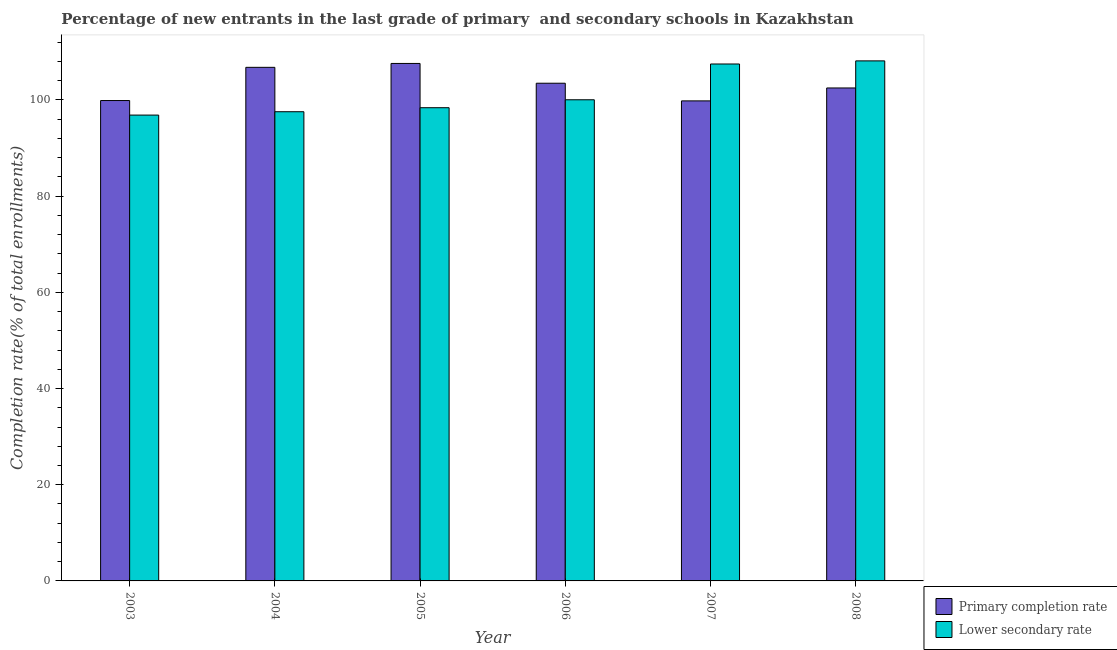How many different coloured bars are there?
Give a very brief answer. 2. Are the number of bars on each tick of the X-axis equal?
Offer a very short reply. Yes. How many bars are there on the 3rd tick from the right?
Offer a terse response. 2. In how many cases, is the number of bars for a given year not equal to the number of legend labels?
Make the answer very short. 0. What is the completion rate in primary schools in 2004?
Provide a succinct answer. 106.78. Across all years, what is the maximum completion rate in primary schools?
Provide a succinct answer. 107.58. Across all years, what is the minimum completion rate in primary schools?
Your answer should be compact. 99.8. In which year was the completion rate in primary schools maximum?
Give a very brief answer. 2005. In which year was the completion rate in primary schools minimum?
Make the answer very short. 2007. What is the total completion rate in secondary schools in the graph?
Give a very brief answer. 608.39. What is the difference between the completion rate in primary schools in 2006 and that in 2007?
Provide a short and direct response. 3.67. What is the difference between the completion rate in primary schools in 2005 and the completion rate in secondary schools in 2008?
Your response must be concise. 5.1. What is the average completion rate in secondary schools per year?
Offer a terse response. 101.4. In the year 2004, what is the difference between the completion rate in primary schools and completion rate in secondary schools?
Your answer should be compact. 0. In how many years, is the completion rate in primary schools greater than 108 %?
Provide a succinct answer. 0. What is the ratio of the completion rate in secondary schools in 2004 to that in 2008?
Make the answer very short. 0.9. Is the completion rate in primary schools in 2004 less than that in 2005?
Your answer should be very brief. Yes. Is the difference between the completion rate in primary schools in 2004 and 2008 greater than the difference between the completion rate in secondary schools in 2004 and 2008?
Your answer should be very brief. No. What is the difference between the highest and the second highest completion rate in secondary schools?
Ensure brevity in your answer.  0.65. What is the difference between the highest and the lowest completion rate in secondary schools?
Your answer should be compact. 11.27. In how many years, is the completion rate in primary schools greater than the average completion rate in primary schools taken over all years?
Ensure brevity in your answer.  3. Is the sum of the completion rate in secondary schools in 2004 and 2008 greater than the maximum completion rate in primary schools across all years?
Give a very brief answer. Yes. What does the 2nd bar from the left in 2005 represents?
Your answer should be very brief. Lower secondary rate. What does the 1st bar from the right in 2005 represents?
Your answer should be compact. Lower secondary rate. Are all the bars in the graph horizontal?
Your answer should be very brief. No. Does the graph contain any zero values?
Keep it short and to the point. No. Does the graph contain grids?
Provide a succinct answer. No. Where does the legend appear in the graph?
Make the answer very short. Bottom right. What is the title of the graph?
Keep it short and to the point. Percentage of new entrants in the last grade of primary  and secondary schools in Kazakhstan. What is the label or title of the Y-axis?
Provide a succinct answer. Completion rate(% of total enrollments). What is the Completion rate(% of total enrollments) of Primary completion rate in 2003?
Your answer should be very brief. 99.87. What is the Completion rate(% of total enrollments) of Lower secondary rate in 2003?
Make the answer very short. 96.85. What is the Completion rate(% of total enrollments) of Primary completion rate in 2004?
Your answer should be compact. 106.78. What is the Completion rate(% of total enrollments) of Lower secondary rate in 2004?
Offer a very short reply. 97.55. What is the Completion rate(% of total enrollments) in Primary completion rate in 2005?
Your response must be concise. 107.58. What is the Completion rate(% of total enrollments) of Lower secondary rate in 2005?
Your response must be concise. 98.38. What is the Completion rate(% of total enrollments) in Primary completion rate in 2006?
Offer a very short reply. 103.47. What is the Completion rate(% of total enrollments) in Lower secondary rate in 2006?
Your answer should be very brief. 100.03. What is the Completion rate(% of total enrollments) in Primary completion rate in 2007?
Give a very brief answer. 99.8. What is the Completion rate(% of total enrollments) in Lower secondary rate in 2007?
Offer a terse response. 107.47. What is the Completion rate(% of total enrollments) of Primary completion rate in 2008?
Your response must be concise. 102.49. What is the Completion rate(% of total enrollments) of Lower secondary rate in 2008?
Ensure brevity in your answer.  108.12. Across all years, what is the maximum Completion rate(% of total enrollments) of Primary completion rate?
Your response must be concise. 107.58. Across all years, what is the maximum Completion rate(% of total enrollments) of Lower secondary rate?
Your answer should be compact. 108.12. Across all years, what is the minimum Completion rate(% of total enrollments) in Primary completion rate?
Make the answer very short. 99.8. Across all years, what is the minimum Completion rate(% of total enrollments) in Lower secondary rate?
Keep it short and to the point. 96.85. What is the total Completion rate(% of total enrollments) in Primary completion rate in the graph?
Offer a very short reply. 619.99. What is the total Completion rate(% of total enrollments) in Lower secondary rate in the graph?
Keep it short and to the point. 608.39. What is the difference between the Completion rate(% of total enrollments) in Primary completion rate in 2003 and that in 2004?
Make the answer very short. -6.9. What is the difference between the Completion rate(% of total enrollments) of Lower secondary rate in 2003 and that in 2004?
Keep it short and to the point. -0.7. What is the difference between the Completion rate(% of total enrollments) in Primary completion rate in 2003 and that in 2005?
Your answer should be compact. -7.71. What is the difference between the Completion rate(% of total enrollments) in Lower secondary rate in 2003 and that in 2005?
Keep it short and to the point. -1.53. What is the difference between the Completion rate(% of total enrollments) of Primary completion rate in 2003 and that in 2006?
Offer a terse response. -3.6. What is the difference between the Completion rate(% of total enrollments) in Lower secondary rate in 2003 and that in 2006?
Your answer should be very brief. -3.18. What is the difference between the Completion rate(% of total enrollments) of Primary completion rate in 2003 and that in 2007?
Your response must be concise. 0.07. What is the difference between the Completion rate(% of total enrollments) in Lower secondary rate in 2003 and that in 2007?
Your answer should be compact. -10.62. What is the difference between the Completion rate(% of total enrollments) in Primary completion rate in 2003 and that in 2008?
Ensure brevity in your answer.  -2.61. What is the difference between the Completion rate(% of total enrollments) in Lower secondary rate in 2003 and that in 2008?
Offer a very short reply. -11.27. What is the difference between the Completion rate(% of total enrollments) in Primary completion rate in 2004 and that in 2005?
Offer a very short reply. -0.81. What is the difference between the Completion rate(% of total enrollments) in Lower secondary rate in 2004 and that in 2005?
Provide a short and direct response. -0.83. What is the difference between the Completion rate(% of total enrollments) of Primary completion rate in 2004 and that in 2006?
Provide a short and direct response. 3.31. What is the difference between the Completion rate(% of total enrollments) in Lower secondary rate in 2004 and that in 2006?
Offer a terse response. -2.49. What is the difference between the Completion rate(% of total enrollments) of Primary completion rate in 2004 and that in 2007?
Provide a succinct answer. 6.98. What is the difference between the Completion rate(% of total enrollments) in Lower secondary rate in 2004 and that in 2007?
Provide a succinct answer. -9.92. What is the difference between the Completion rate(% of total enrollments) of Primary completion rate in 2004 and that in 2008?
Provide a succinct answer. 4.29. What is the difference between the Completion rate(% of total enrollments) in Lower secondary rate in 2004 and that in 2008?
Keep it short and to the point. -10.57. What is the difference between the Completion rate(% of total enrollments) of Primary completion rate in 2005 and that in 2006?
Your answer should be very brief. 4.11. What is the difference between the Completion rate(% of total enrollments) in Lower secondary rate in 2005 and that in 2006?
Your response must be concise. -1.65. What is the difference between the Completion rate(% of total enrollments) of Primary completion rate in 2005 and that in 2007?
Provide a short and direct response. 7.78. What is the difference between the Completion rate(% of total enrollments) of Lower secondary rate in 2005 and that in 2007?
Your answer should be compact. -9.09. What is the difference between the Completion rate(% of total enrollments) of Primary completion rate in 2005 and that in 2008?
Your response must be concise. 5.1. What is the difference between the Completion rate(% of total enrollments) in Lower secondary rate in 2005 and that in 2008?
Your answer should be very brief. -9.74. What is the difference between the Completion rate(% of total enrollments) in Primary completion rate in 2006 and that in 2007?
Your answer should be very brief. 3.67. What is the difference between the Completion rate(% of total enrollments) in Lower secondary rate in 2006 and that in 2007?
Keep it short and to the point. -7.44. What is the difference between the Completion rate(% of total enrollments) in Primary completion rate in 2006 and that in 2008?
Keep it short and to the point. 0.98. What is the difference between the Completion rate(% of total enrollments) of Lower secondary rate in 2006 and that in 2008?
Offer a terse response. -8.09. What is the difference between the Completion rate(% of total enrollments) of Primary completion rate in 2007 and that in 2008?
Keep it short and to the point. -2.69. What is the difference between the Completion rate(% of total enrollments) in Lower secondary rate in 2007 and that in 2008?
Your answer should be compact. -0.65. What is the difference between the Completion rate(% of total enrollments) of Primary completion rate in 2003 and the Completion rate(% of total enrollments) of Lower secondary rate in 2004?
Your response must be concise. 2.33. What is the difference between the Completion rate(% of total enrollments) in Primary completion rate in 2003 and the Completion rate(% of total enrollments) in Lower secondary rate in 2005?
Keep it short and to the point. 1.49. What is the difference between the Completion rate(% of total enrollments) of Primary completion rate in 2003 and the Completion rate(% of total enrollments) of Lower secondary rate in 2006?
Your answer should be compact. -0.16. What is the difference between the Completion rate(% of total enrollments) in Primary completion rate in 2003 and the Completion rate(% of total enrollments) in Lower secondary rate in 2007?
Your answer should be compact. -7.6. What is the difference between the Completion rate(% of total enrollments) in Primary completion rate in 2003 and the Completion rate(% of total enrollments) in Lower secondary rate in 2008?
Provide a succinct answer. -8.25. What is the difference between the Completion rate(% of total enrollments) of Primary completion rate in 2004 and the Completion rate(% of total enrollments) of Lower secondary rate in 2005?
Your answer should be very brief. 8.4. What is the difference between the Completion rate(% of total enrollments) of Primary completion rate in 2004 and the Completion rate(% of total enrollments) of Lower secondary rate in 2006?
Your answer should be very brief. 6.74. What is the difference between the Completion rate(% of total enrollments) in Primary completion rate in 2004 and the Completion rate(% of total enrollments) in Lower secondary rate in 2007?
Your answer should be compact. -0.69. What is the difference between the Completion rate(% of total enrollments) of Primary completion rate in 2004 and the Completion rate(% of total enrollments) of Lower secondary rate in 2008?
Provide a succinct answer. -1.34. What is the difference between the Completion rate(% of total enrollments) of Primary completion rate in 2005 and the Completion rate(% of total enrollments) of Lower secondary rate in 2006?
Make the answer very short. 7.55. What is the difference between the Completion rate(% of total enrollments) in Primary completion rate in 2005 and the Completion rate(% of total enrollments) in Lower secondary rate in 2007?
Ensure brevity in your answer.  0.11. What is the difference between the Completion rate(% of total enrollments) of Primary completion rate in 2005 and the Completion rate(% of total enrollments) of Lower secondary rate in 2008?
Give a very brief answer. -0.53. What is the difference between the Completion rate(% of total enrollments) in Primary completion rate in 2006 and the Completion rate(% of total enrollments) in Lower secondary rate in 2007?
Your response must be concise. -4. What is the difference between the Completion rate(% of total enrollments) in Primary completion rate in 2006 and the Completion rate(% of total enrollments) in Lower secondary rate in 2008?
Ensure brevity in your answer.  -4.65. What is the difference between the Completion rate(% of total enrollments) of Primary completion rate in 2007 and the Completion rate(% of total enrollments) of Lower secondary rate in 2008?
Provide a succinct answer. -8.32. What is the average Completion rate(% of total enrollments) in Primary completion rate per year?
Your answer should be compact. 103.33. What is the average Completion rate(% of total enrollments) in Lower secondary rate per year?
Keep it short and to the point. 101.4. In the year 2003, what is the difference between the Completion rate(% of total enrollments) in Primary completion rate and Completion rate(% of total enrollments) in Lower secondary rate?
Give a very brief answer. 3.02. In the year 2004, what is the difference between the Completion rate(% of total enrollments) of Primary completion rate and Completion rate(% of total enrollments) of Lower secondary rate?
Your response must be concise. 9.23. In the year 2005, what is the difference between the Completion rate(% of total enrollments) in Primary completion rate and Completion rate(% of total enrollments) in Lower secondary rate?
Make the answer very short. 9.2. In the year 2006, what is the difference between the Completion rate(% of total enrollments) in Primary completion rate and Completion rate(% of total enrollments) in Lower secondary rate?
Ensure brevity in your answer.  3.44. In the year 2007, what is the difference between the Completion rate(% of total enrollments) of Primary completion rate and Completion rate(% of total enrollments) of Lower secondary rate?
Provide a succinct answer. -7.67. In the year 2008, what is the difference between the Completion rate(% of total enrollments) in Primary completion rate and Completion rate(% of total enrollments) in Lower secondary rate?
Offer a terse response. -5.63. What is the ratio of the Completion rate(% of total enrollments) in Primary completion rate in 2003 to that in 2004?
Ensure brevity in your answer.  0.94. What is the ratio of the Completion rate(% of total enrollments) in Lower secondary rate in 2003 to that in 2004?
Your response must be concise. 0.99. What is the ratio of the Completion rate(% of total enrollments) in Primary completion rate in 2003 to that in 2005?
Your answer should be compact. 0.93. What is the ratio of the Completion rate(% of total enrollments) of Lower secondary rate in 2003 to that in 2005?
Keep it short and to the point. 0.98. What is the ratio of the Completion rate(% of total enrollments) of Primary completion rate in 2003 to that in 2006?
Give a very brief answer. 0.97. What is the ratio of the Completion rate(% of total enrollments) in Lower secondary rate in 2003 to that in 2006?
Make the answer very short. 0.97. What is the ratio of the Completion rate(% of total enrollments) of Lower secondary rate in 2003 to that in 2007?
Offer a very short reply. 0.9. What is the ratio of the Completion rate(% of total enrollments) of Primary completion rate in 2003 to that in 2008?
Offer a very short reply. 0.97. What is the ratio of the Completion rate(% of total enrollments) in Lower secondary rate in 2003 to that in 2008?
Give a very brief answer. 0.9. What is the ratio of the Completion rate(% of total enrollments) of Primary completion rate in 2004 to that in 2005?
Ensure brevity in your answer.  0.99. What is the ratio of the Completion rate(% of total enrollments) of Lower secondary rate in 2004 to that in 2005?
Ensure brevity in your answer.  0.99. What is the ratio of the Completion rate(% of total enrollments) in Primary completion rate in 2004 to that in 2006?
Give a very brief answer. 1.03. What is the ratio of the Completion rate(% of total enrollments) in Lower secondary rate in 2004 to that in 2006?
Provide a succinct answer. 0.98. What is the ratio of the Completion rate(% of total enrollments) of Primary completion rate in 2004 to that in 2007?
Ensure brevity in your answer.  1.07. What is the ratio of the Completion rate(% of total enrollments) in Lower secondary rate in 2004 to that in 2007?
Give a very brief answer. 0.91. What is the ratio of the Completion rate(% of total enrollments) of Primary completion rate in 2004 to that in 2008?
Keep it short and to the point. 1.04. What is the ratio of the Completion rate(% of total enrollments) of Lower secondary rate in 2004 to that in 2008?
Your response must be concise. 0.9. What is the ratio of the Completion rate(% of total enrollments) of Primary completion rate in 2005 to that in 2006?
Keep it short and to the point. 1.04. What is the ratio of the Completion rate(% of total enrollments) in Lower secondary rate in 2005 to that in 2006?
Keep it short and to the point. 0.98. What is the ratio of the Completion rate(% of total enrollments) in Primary completion rate in 2005 to that in 2007?
Your answer should be very brief. 1.08. What is the ratio of the Completion rate(% of total enrollments) of Lower secondary rate in 2005 to that in 2007?
Offer a terse response. 0.92. What is the ratio of the Completion rate(% of total enrollments) in Primary completion rate in 2005 to that in 2008?
Give a very brief answer. 1.05. What is the ratio of the Completion rate(% of total enrollments) in Lower secondary rate in 2005 to that in 2008?
Make the answer very short. 0.91. What is the ratio of the Completion rate(% of total enrollments) of Primary completion rate in 2006 to that in 2007?
Offer a very short reply. 1.04. What is the ratio of the Completion rate(% of total enrollments) in Lower secondary rate in 2006 to that in 2007?
Offer a terse response. 0.93. What is the ratio of the Completion rate(% of total enrollments) of Primary completion rate in 2006 to that in 2008?
Offer a very short reply. 1.01. What is the ratio of the Completion rate(% of total enrollments) in Lower secondary rate in 2006 to that in 2008?
Keep it short and to the point. 0.93. What is the ratio of the Completion rate(% of total enrollments) in Primary completion rate in 2007 to that in 2008?
Your response must be concise. 0.97. What is the ratio of the Completion rate(% of total enrollments) of Lower secondary rate in 2007 to that in 2008?
Make the answer very short. 0.99. What is the difference between the highest and the second highest Completion rate(% of total enrollments) in Primary completion rate?
Give a very brief answer. 0.81. What is the difference between the highest and the second highest Completion rate(% of total enrollments) of Lower secondary rate?
Give a very brief answer. 0.65. What is the difference between the highest and the lowest Completion rate(% of total enrollments) in Primary completion rate?
Your answer should be compact. 7.78. What is the difference between the highest and the lowest Completion rate(% of total enrollments) of Lower secondary rate?
Offer a very short reply. 11.27. 